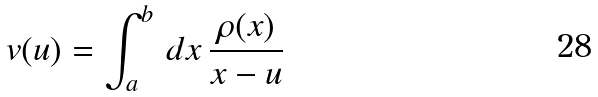<formula> <loc_0><loc_0><loc_500><loc_500>v ( u ) = \int _ { a } ^ { b } \, d x \, \frac { \rho ( x ) } { x - u }</formula> 